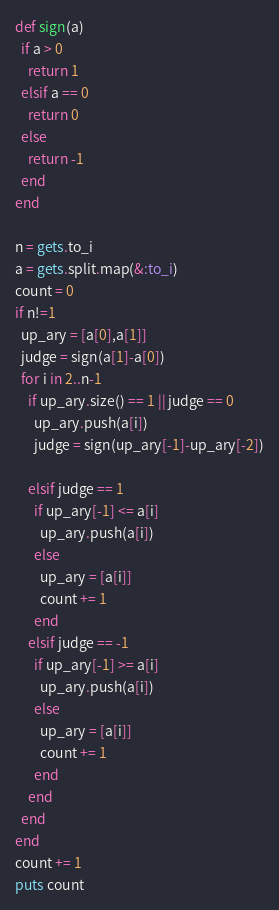Convert code to text. <code><loc_0><loc_0><loc_500><loc_500><_Ruby_>def sign(a)
  if a > 0
    return 1
  elsif a == 0
    return 0
  else
    return -1
  end
end

n = gets.to_i
a = gets.split.map(&:to_i)
count = 0
if n!=1
  up_ary = [a[0],a[1]]
  judge = sign(a[1]-a[0])
  for i in 2..n-1
    if up_ary.size() == 1 || judge == 0
      up_ary.push(a[i])
      judge = sign(up_ary[-1]-up_ary[-2])

    elsif judge == 1
      if up_ary[-1] <= a[i]
        up_ary.push(a[i])
      else
        up_ary = [a[i]]
        count += 1
      end
    elsif judge == -1
      if up_ary[-1] >= a[i]
        up_ary.push(a[i])
      else
        up_ary = [a[i]]
        count += 1
      end
    end
  end
end
count += 1
puts count</code> 